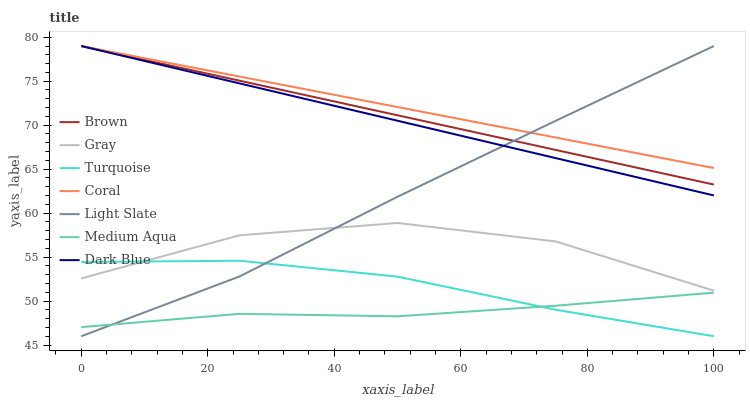Does Medium Aqua have the minimum area under the curve?
Answer yes or no. Yes. Does Coral have the maximum area under the curve?
Answer yes or no. Yes. Does Turquoise have the minimum area under the curve?
Answer yes or no. No. Does Turquoise have the maximum area under the curve?
Answer yes or no. No. Is Brown the smoothest?
Answer yes or no. Yes. Is Gray the roughest?
Answer yes or no. Yes. Is Turquoise the smoothest?
Answer yes or no. No. Is Turquoise the roughest?
Answer yes or no. No. Does Turquoise have the lowest value?
Answer yes or no. Yes. Does Gray have the lowest value?
Answer yes or no. No. Does Dark Blue have the highest value?
Answer yes or no. Yes. Does Turquoise have the highest value?
Answer yes or no. No. Is Gray less than Coral?
Answer yes or no. Yes. Is Coral greater than Turquoise?
Answer yes or no. Yes. Does Medium Aqua intersect Turquoise?
Answer yes or no. Yes. Is Medium Aqua less than Turquoise?
Answer yes or no. No. Is Medium Aqua greater than Turquoise?
Answer yes or no. No. Does Gray intersect Coral?
Answer yes or no. No. 